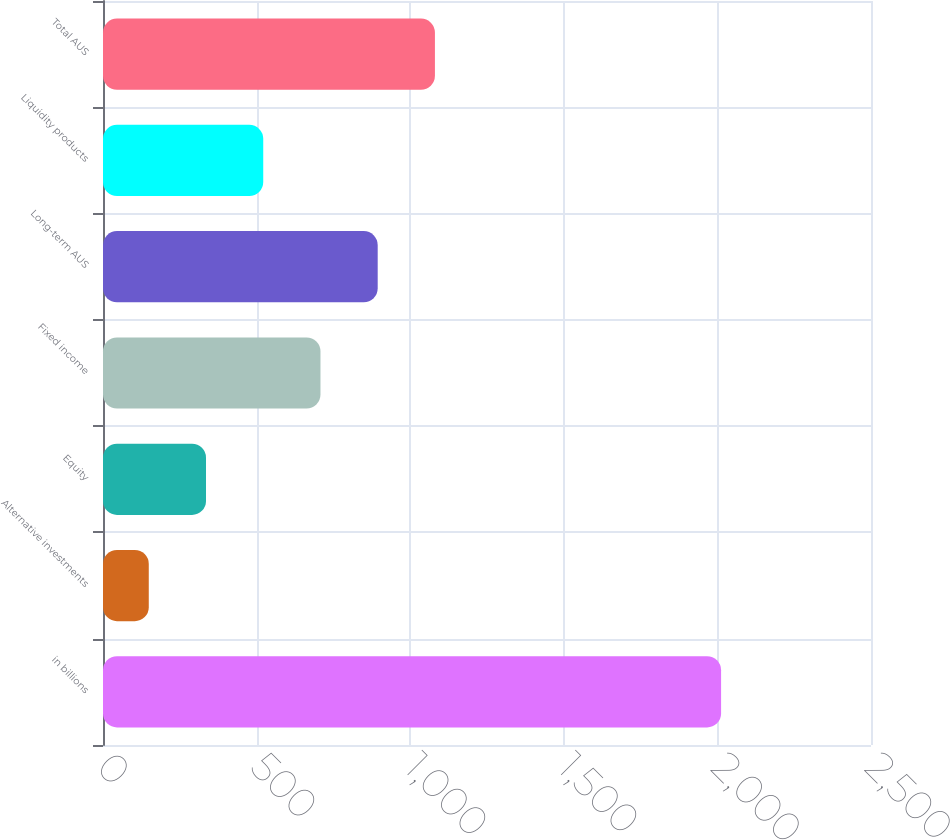<chart> <loc_0><loc_0><loc_500><loc_500><bar_chart><fcel>in billions<fcel>Alternative investments<fcel>Equity<fcel>Fixed income<fcel>Long-term AUS<fcel>Liquidity products<fcel>Total AUS<nl><fcel>2012<fcel>149<fcel>335.3<fcel>707.9<fcel>894.2<fcel>521.6<fcel>1080.5<nl></chart> 